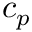Convert formula to latex. <formula><loc_0><loc_0><loc_500><loc_500>c _ { p }</formula> 